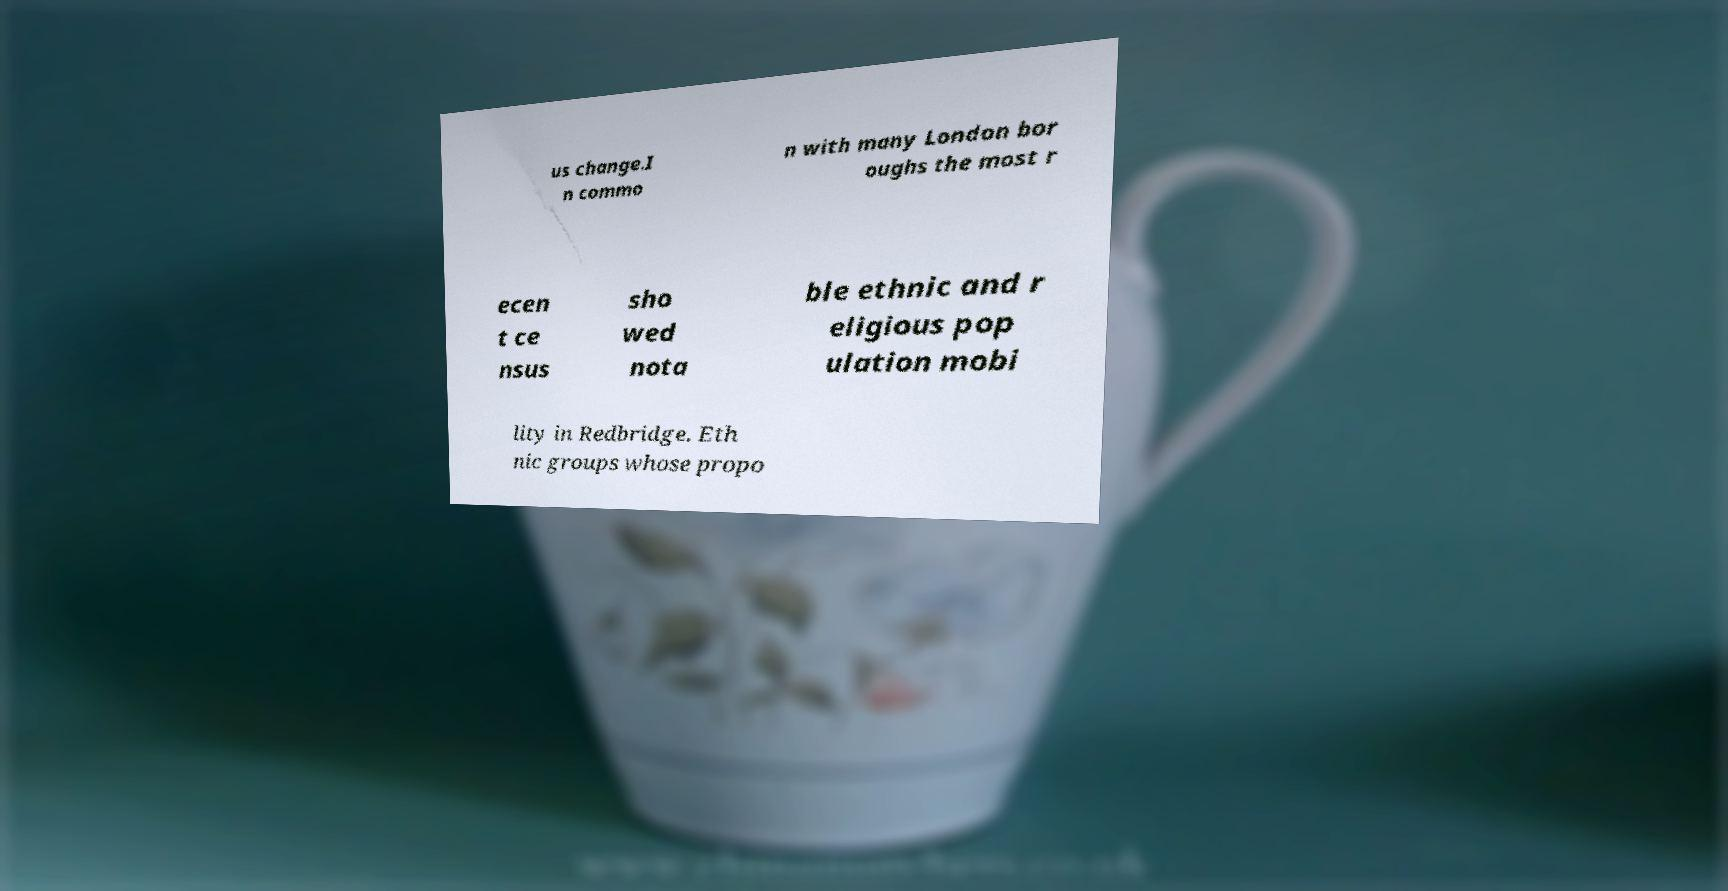For documentation purposes, I need the text within this image transcribed. Could you provide that? us change.I n commo n with many London bor oughs the most r ecen t ce nsus sho wed nota ble ethnic and r eligious pop ulation mobi lity in Redbridge. Eth nic groups whose propo 